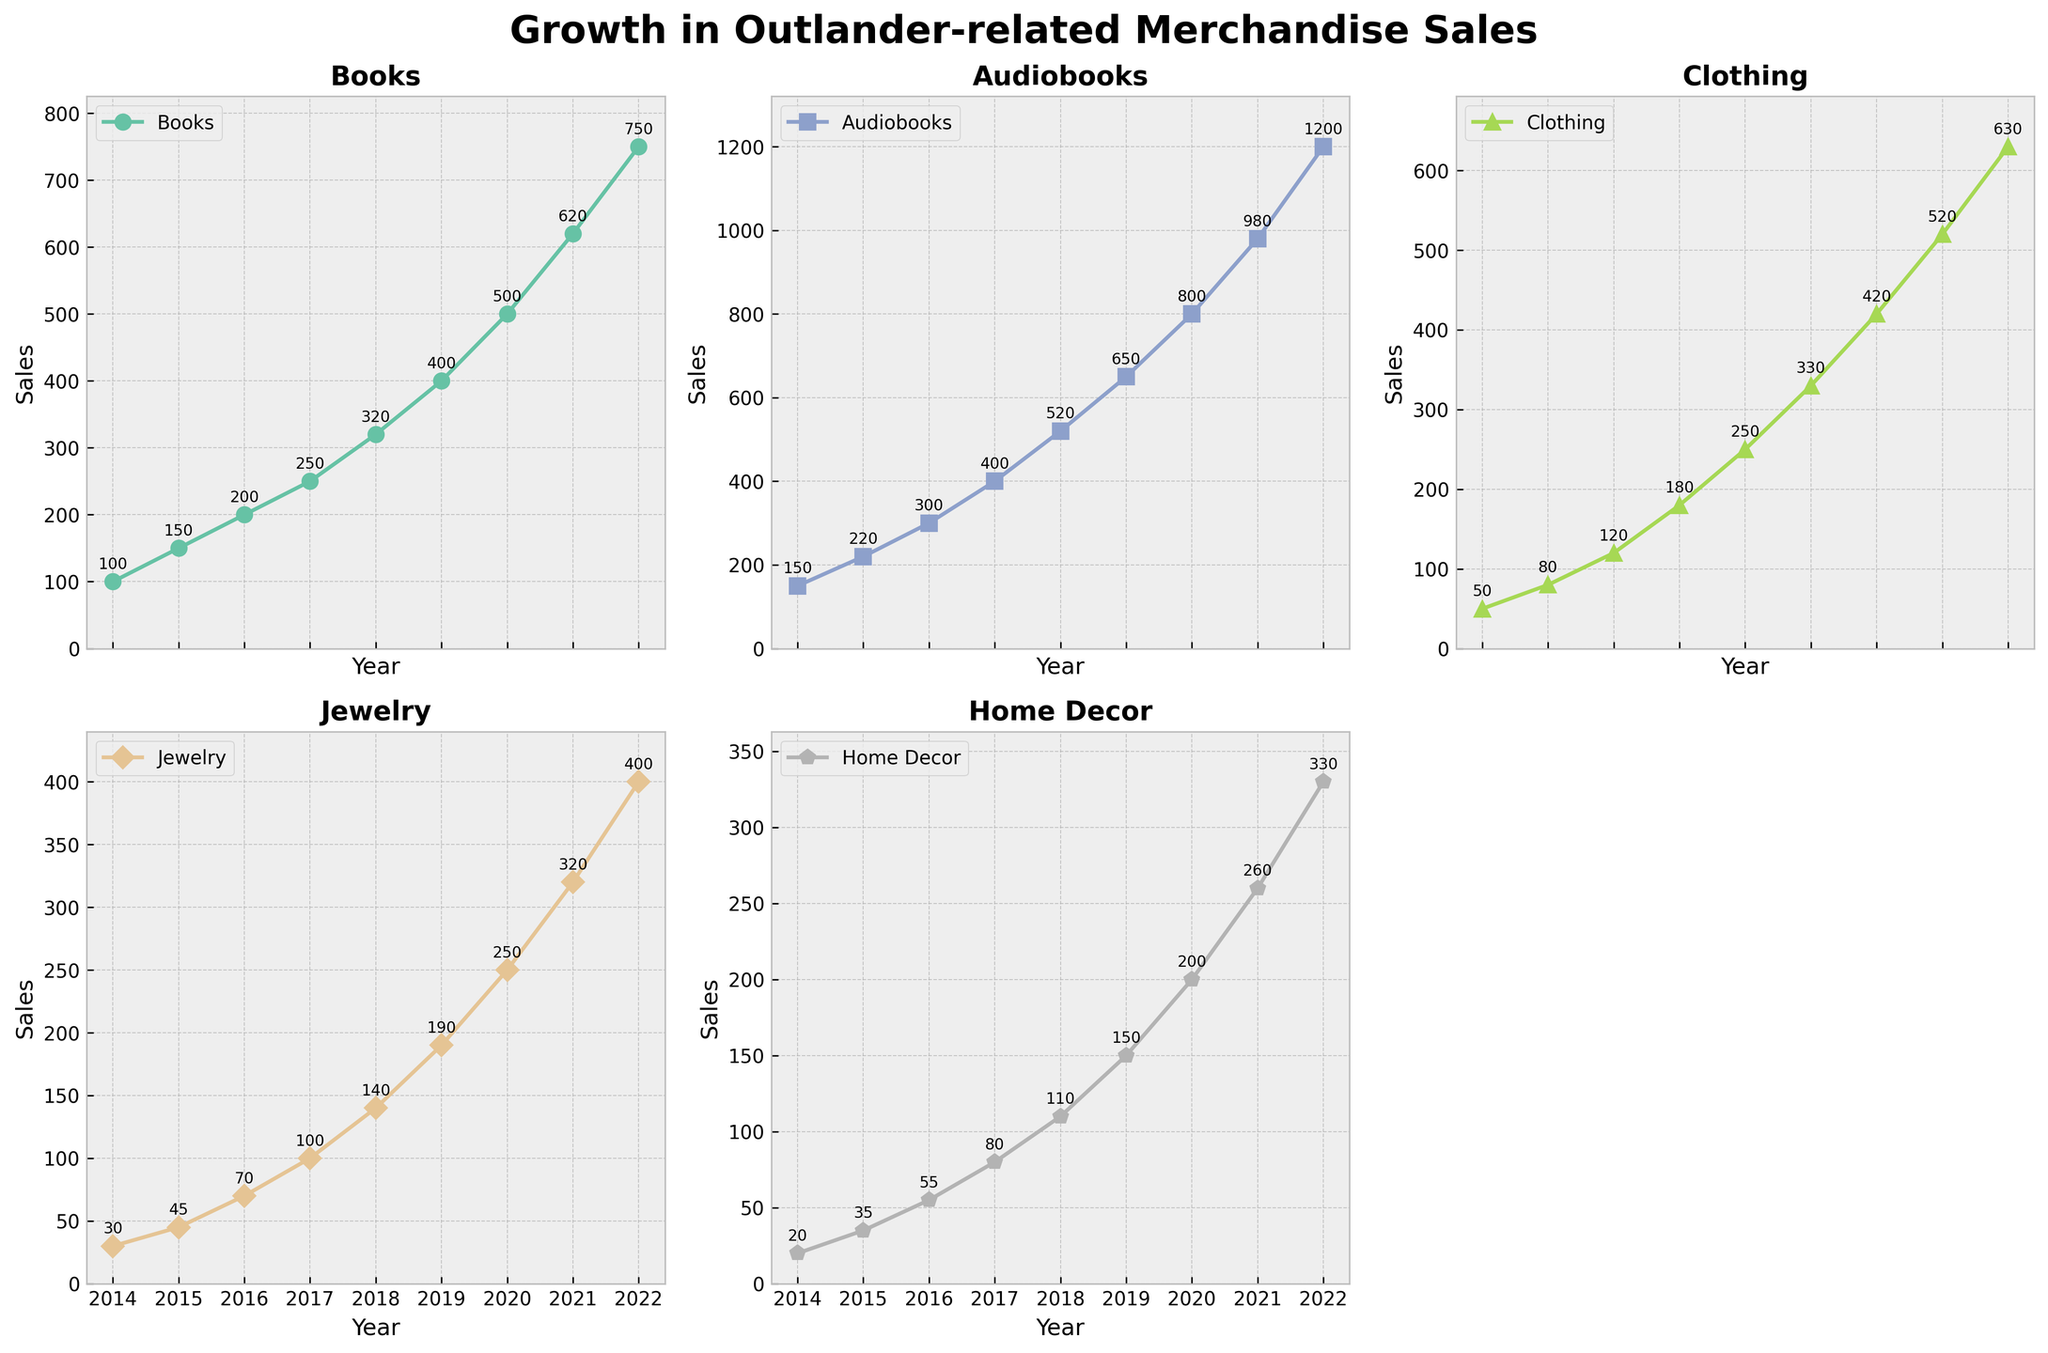What is the title of the figure? The title of the figure is prominently displayed at the top of the image. The title can usually be found at the top center of a plot, summarizing the content of the figure in a concise phrase.
Answer: Growth in Outlander-related Merchandise Sales What is the sales value for Clothing in 2016? Locate the line representing Clothing, find the year 2016 along the x-axis, and then move vertically to the point where the line intersects the year 2016.
Answer: 120 Which product category had the highest sales in 2020? Compare the sales values of all categories for the year 2020 by locating the respective points along the different colored lines on the plot.
Answer: Audiobooks How did the sales of Jewelry change from 2014 to 2022? Identify the sales points for Jewelry in the years 2014 and 2022 respectively, and observe the difference. Sales in 2014 were 30 and in 2022 were 400, indicating a steady increase over the years.
Answer: Steadily Increased What was the combined sales value for Books and Home Decor in 2019? Find the sales values for Books and Home Decor in 2019 separately, which are 400 for Books and 150 for Home Decor, and add these values together.
Answer: 550 Which category experienced the largest increase in sales from 2017 to 2018? Determine the difference in sales for each category between 2017 and 2018. The increments are: Books (+70), Audiobooks (+120), Clothing (+70), Jewelry (+40), Home Decor (+30).
Answer: Audiobooks Which category had the slowest growth in sales over the period depicted in the plot? Compare the initial and final sales figures for each category. Calculating the growth: Books (750-100=650), Audiobooks (1200-150=1050), Clothing (630-50=580), Jewelry (400-30=370), Home Decor (330-20=310).
Answer: Home Decor In which years did the sales of Audiobooks overtake the sales of Books? Identify the points where the Audiobooks line surpasses the Books line by observing the intersecting points and where the Audiobooks line remains higher. This happened starting from 2015 onwards.
Answer: 2015 onwards Which two product categories had the closest sales values in 2022? Compare the ending points (2022) of all the lines to find which two categories have sales values closest to each other. Home Decor (330) and Jewelry (400) have the closest sales figures.
Answer: Home Decor and Jewelry 